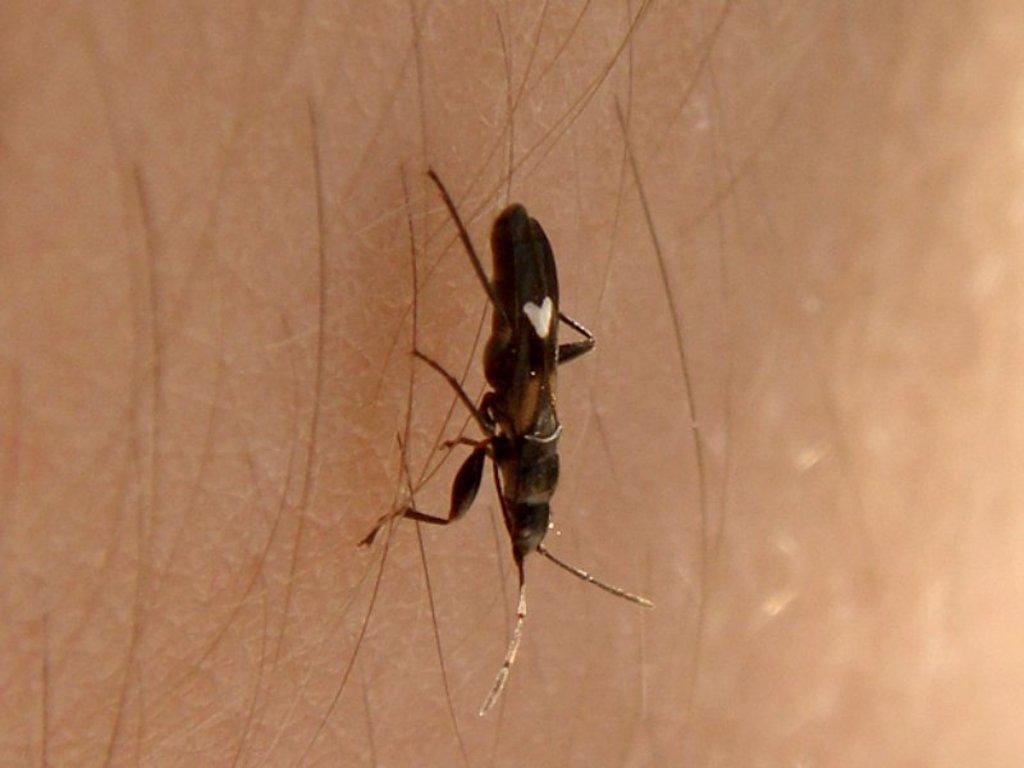What is the main subject in the center of the image? There is an insect in the center of the image. What can be seen in the background of the image? There is skin and hair visible in the background of the image. How many levels of the whip can be seen in the image? There is no whip present in the image. What type of finger is visible in the image? There is no finger visible in the image. 